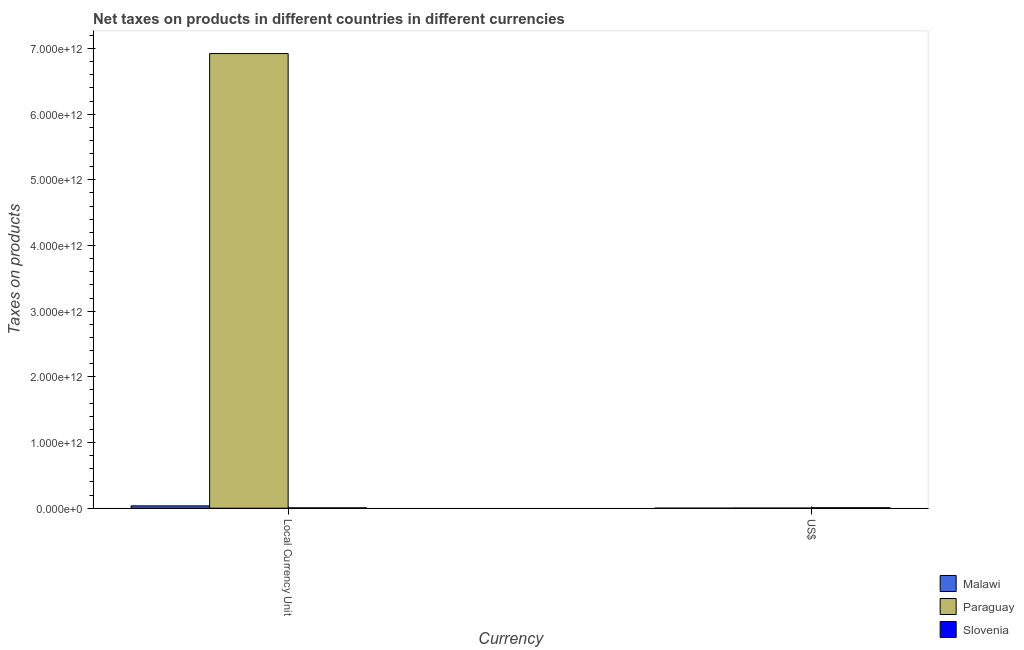How many groups of bars are there?
Keep it short and to the point. 2. Are the number of bars per tick equal to the number of legend labels?
Your answer should be compact. Yes. What is the label of the 2nd group of bars from the left?
Offer a very short reply. US$. What is the net taxes in constant 2005 us$ in Malawi?
Offer a very short reply. 3.60e+1. Across all countries, what is the maximum net taxes in us$?
Provide a short and direct response. 6.92e+09. Across all countries, what is the minimum net taxes in constant 2005 us$?
Your response must be concise. 4.72e+09. In which country was the net taxes in us$ maximum?
Ensure brevity in your answer.  Slovenia. In which country was the net taxes in constant 2005 us$ minimum?
Your answer should be very brief. Slovenia. What is the total net taxes in constant 2005 us$ in the graph?
Provide a succinct answer. 6.96e+12. What is the difference between the net taxes in us$ in Malawi and that in Slovenia?
Your response must be concise. -6.66e+09. What is the difference between the net taxes in us$ in Slovenia and the net taxes in constant 2005 us$ in Paraguay?
Offer a very short reply. -6.92e+12. What is the average net taxes in us$ per country?
Provide a short and direct response. 2.92e+09. What is the difference between the net taxes in us$ and net taxes in constant 2005 us$ in Malawi?
Offer a very short reply. -3.57e+1. In how many countries, is the net taxes in constant 2005 us$ greater than 3800000000000 units?
Offer a terse response. 1. What is the ratio of the net taxes in constant 2005 us$ in Paraguay to that in Malawi?
Provide a short and direct response. 192.5. Is the net taxes in constant 2005 us$ in Slovenia less than that in Malawi?
Give a very brief answer. Yes. What does the 3rd bar from the left in US$ represents?
Your answer should be compact. Slovenia. What does the 3rd bar from the right in US$ represents?
Provide a short and direct response. Malawi. How many countries are there in the graph?
Give a very brief answer. 3. What is the difference between two consecutive major ticks on the Y-axis?
Ensure brevity in your answer.  1.00e+12. Are the values on the major ticks of Y-axis written in scientific E-notation?
Make the answer very short. Yes. Does the graph contain any zero values?
Ensure brevity in your answer.  No. Does the graph contain grids?
Ensure brevity in your answer.  No. Where does the legend appear in the graph?
Ensure brevity in your answer.  Bottom right. How many legend labels are there?
Your answer should be compact. 3. How are the legend labels stacked?
Provide a short and direct response. Vertical. What is the title of the graph?
Offer a terse response. Net taxes on products in different countries in different currencies. What is the label or title of the X-axis?
Your answer should be very brief. Currency. What is the label or title of the Y-axis?
Offer a very short reply. Taxes on products. What is the Taxes on products in Malawi in Local Currency Unit?
Your answer should be compact. 3.60e+1. What is the Taxes on products in Paraguay in Local Currency Unit?
Provide a short and direct response. 6.92e+12. What is the Taxes on products of Slovenia in Local Currency Unit?
Make the answer very short. 4.72e+09. What is the Taxes on products of Malawi in US$?
Make the answer very short. 2.56e+08. What is the Taxes on products in Paraguay in US$?
Give a very brief answer. 1.59e+09. What is the Taxes on products in Slovenia in US$?
Keep it short and to the point. 6.92e+09. Across all Currency, what is the maximum Taxes on products of Malawi?
Provide a short and direct response. 3.60e+1. Across all Currency, what is the maximum Taxes on products in Paraguay?
Keep it short and to the point. 6.92e+12. Across all Currency, what is the maximum Taxes on products in Slovenia?
Ensure brevity in your answer.  6.92e+09. Across all Currency, what is the minimum Taxes on products of Malawi?
Make the answer very short. 2.56e+08. Across all Currency, what is the minimum Taxes on products of Paraguay?
Offer a very short reply. 1.59e+09. Across all Currency, what is the minimum Taxes on products of Slovenia?
Give a very brief answer. 4.72e+09. What is the total Taxes on products in Malawi in the graph?
Provide a short and direct response. 3.62e+1. What is the total Taxes on products of Paraguay in the graph?
Your answer should be very brief. 6.92e+12. What is the total Taxes on products of Slovenia in the graph?
Give a very brief answer. 1.16e+1. What is the difference between the Taxes on products in Malawi in Local Currency Unit and that in US$?
Offer a terse response. 3.57e+1. What is the difference between the Taxes on products of Paraguay in Local Currency Unit and that in US$?
Your answer should be compact. 6.92e+12. What is the difference between the Taxes on products of Slovenia in Local Currency Unit and that in US$?
Provide a succinct answer. -2.19e+09. What is the difference between the Taxes on products in Malawi in Local Currency Unit and the Taxes on products in Paraguay in US$?
Ensure brevity in your answer.  3.44e+1. What is the difference between the Taxes on products of Malawi in Local Currency Unit and the Taxes on products of Slovenia in US$?
Offer a terse response. 2.90e+1. What is the difference between the Taxes on products of Paraguay in Local Currency Unit and the Taxes on products of Slovenia in US$?
Provide a succinct answer. 6.92e+12. What is the average Taxes on products of Malawi per Currency?
Offer a very short reply. 1.81e+1. What is the average Taxes on products in Paraguay per Currency?
Offer a very short reply. 3.46e+12. What is the average Taxes on products of Slovenia per Currency?
Your response must be concise. 5.82e+09. What is the difference between the Taxes on products in Malawi and Taxes on products in Paraguay in Local Currency Unit?
Ensure brevity in your answer.  -6.89e+12. What is the difference between the Taxes on products of Malawi and Taxes on products of Slovenia in Local Currency Unit?
Provide a short and direct response. 3.12e+1. What is the difference between the Taxes on products of Paraguay and Taxes on products of Slovenia in Local Currency Unit?
Offer a terse response. 6.92e+12. What is the difference between the Taxes on products in Malawi and Taxes on products in Paraguay in US$?
Give a very brief answer. -1.33e+09. What is the difference between the Taxes on products of Malawi and Taxes on products of Slovenia in US$?
Your response must be concise. -6.66e+09. What is the difference between the Taxes on products in Paraguay and Taxes on products in Slovenia in US$?
Your answer should be compact. -5.33e+09. What is the ratio of the Taxes on products of Malawi in Local Currency Unit to that in US$?
Ensure brevity in your answer.  140.52. What is the ratio of the Taxes on products in Paraguay in Local Currency Unit to that in US$?
Make the answer very short. 4363.07. What is the ratio of the Taxes on products in Slovenia in Local Currency Unit to that in US$?
Offer a terse response. 0.68. What is the difference between the highest and the second highest Taxes on products in Malawi?
Give a very brief answer. 3.57e+1. What is the difference between the highest and the second highest Taxes on products of Paraguay?
Provide a short and direct response. 6.92e+12. What is the difference between the highest and the second highest Taxes on products in Slovenia?
Ensure brevity in your answer.  2.19e+09. What is the difference between the highest and the lowest Taxes on products of Malawi?
Give a very brief answer. 3.57e+1. What is the difference between the highest and the lowest Taxes on products in Paraguay?
Make the answer very short. 6.92e+12. What is the difference between the highest and the lowest Taxes on products in Slovenia?
Keep it short and to the point. 2.19e+09. 